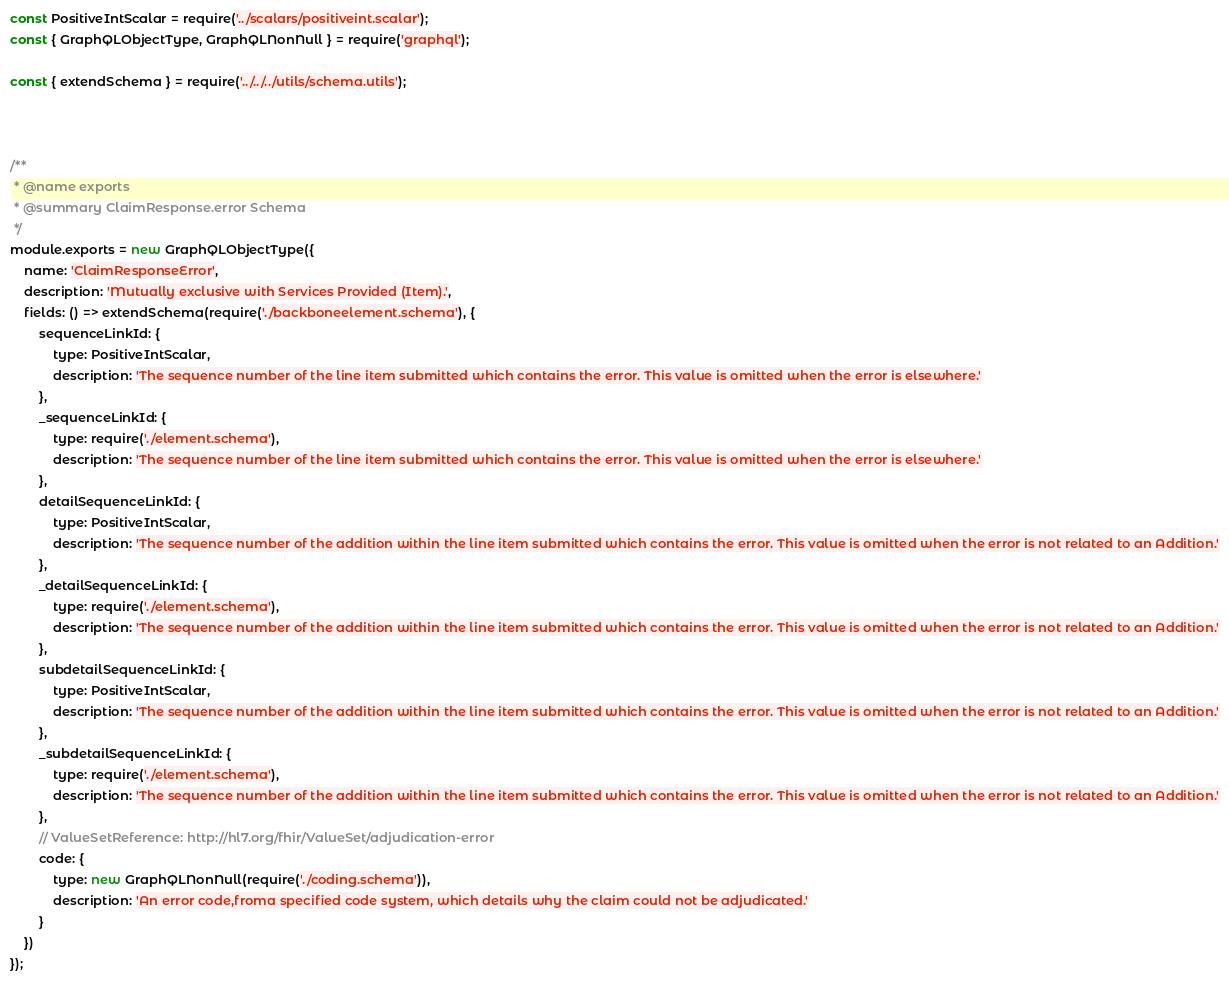Convert code to text. <code><loc_0><loc_0><loc_500><loc_500><_JavaScript_>const PositiveIntScalar = require('../scalars/positiveint.scalar');
const { GraphQLObjectType, GraphQLNonNull } = require('graphql');

const { extendSchema } = require('../../../utils/schema.utils');



/**
 * @name exports
 * @summary ClaimResponse.error Schema
 */
module.exports = new GraphQLObjectType({
	name: 'ClaimResponseError',
	description: 'Mutually exclusive with Services Provided (Item).',
	fields: () => extendSchema(require('./backboneelement.schema'), {
		sequenceLinkId: {
			type: PositiveIntScalar,
			description: 'The sequence number of the line item submitted which contains the error. This value is omitted when the error is elsewhere.'
		},
		_sequenceLinkId: {
			type: require('./element.schema'),
			description: 'The sequence number of the line item submitted which contains the error. This value is omitted when the error is elsewhere.'
		},
		detailSequenceLinkId: {
			type: PositiveIntScalar,
			description: 'The sequence number of the addition within the line item submitted which contains the error. This value is omitted when the error is not related to an Addition.'
		},
		_detailSequenceLinkId: {
			type: require('./element.schema'),
			description: 'The sequence number of the addition within the line item submitted which contains the error. This value is omitted when the error is not related to an Addition.'
		},
		subdetailSequenceLinkId: {
			type: PositiveIntScalar,
			description: 'The sequence number of the addition within the line item submitted which contains the error. This value is omitted when the error is not related to an Addition.'
		},
		_subdetailSequenceLinkId: {
			type: require('./element.schema'),
			description: 'The sequence number of the addition within the line item submitted which contains the error. This value is omitted when the error is not related to an Addition.'
		},
		// ValueSetReference: http://hl7.org/fhir/ValueSet/adjudication-error
		code: {
			type: new GraphQLNonNull(require('./coding.schema')),
			description: 'An error code,froma specified code system, which details why the claim could not be adjudicated.'
		}
	})
});
</code> 